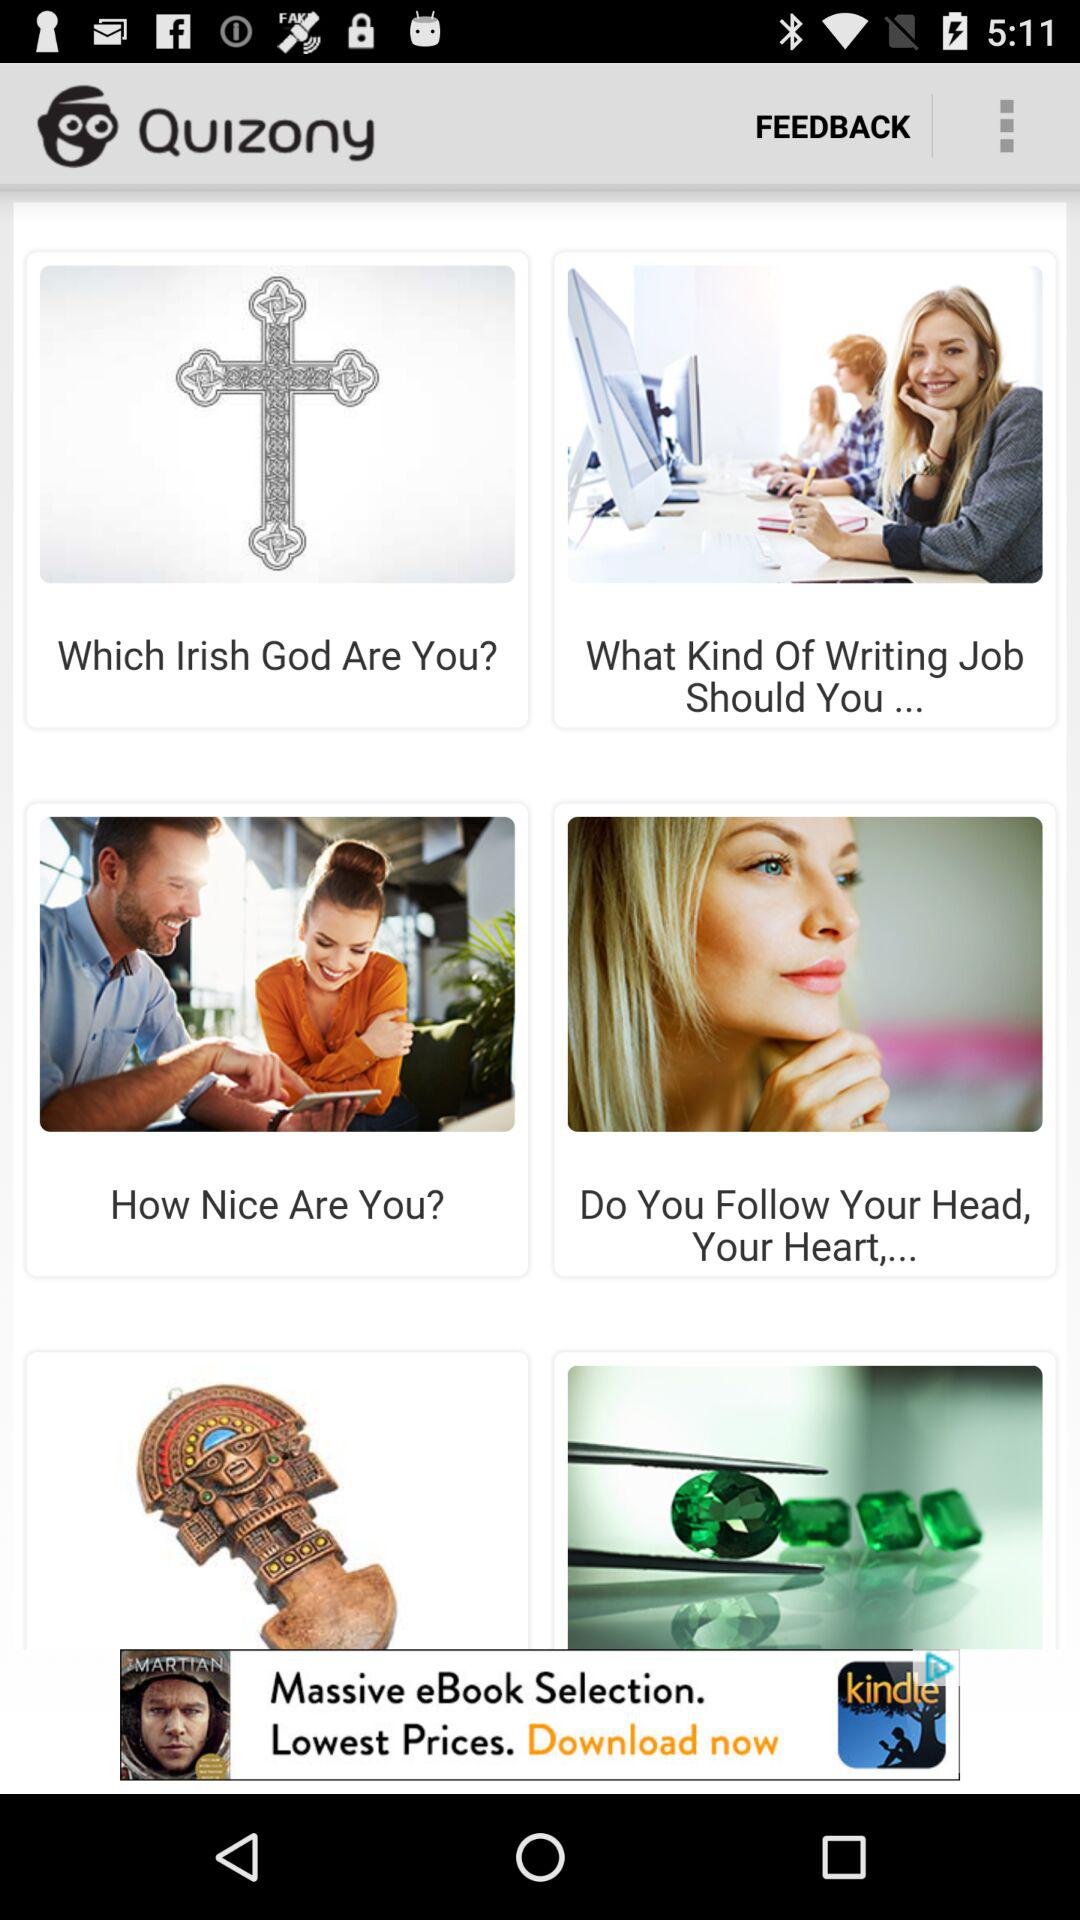What is the name of the application? The name of the application is "Quizony". 